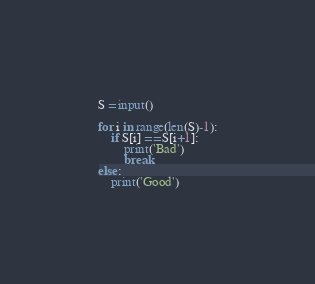<code> <loc_0><loc_0><loc_500><loc_500><_Python_>S = input()

for i in range(len(S)-1):
    if S[i] == S[i+1]:
        print('Bad')
        break
else:
    print('Good')</code> 